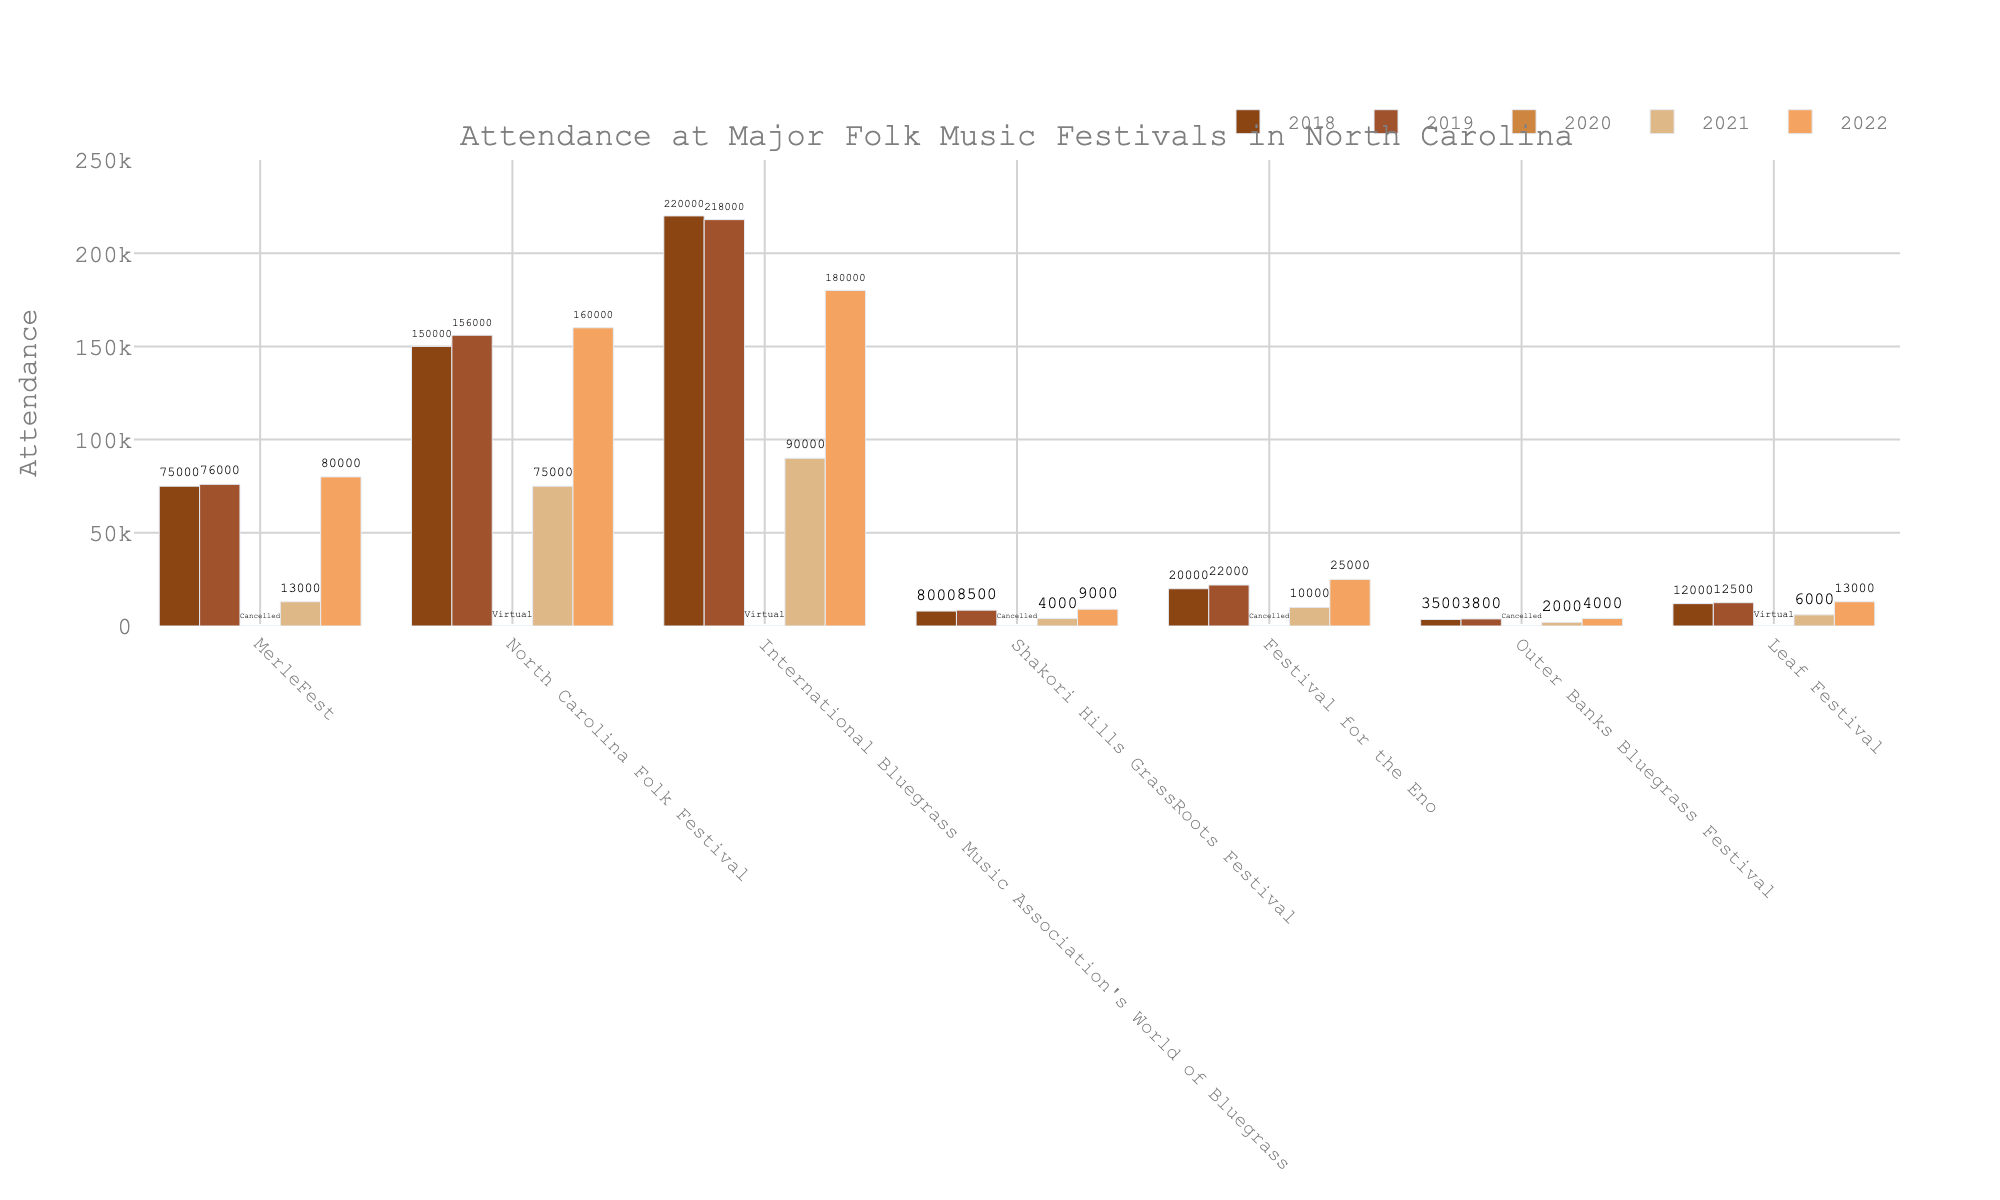Which festival had the highest attendance in 2022? Look for the tallest bar in the 2022 group. The "North Carolina Folk Festival" has the highest attendance with the tallest bar.
Answer: North Carolina Folk Festival How did the attendance for the "MerleFest" change from 2021 to 2022? Compare the bar heights for "MerleFest" between 2021 (13,000) and 2022 (80,000). The attendance increased.
Answer: Increased Which festivals were cancelled in 2020? Look for the festivals with a bar height of zero and having the label "Cancelled" in 2020. These are "MerleFest," "Shakori Hills GrassRoots Festival," "Festival for the Eno," and "Outer Banks Bluegrass Festival".
Answer: MerleFest, Shakori Hills GrassRoots Festival, Festival for the Eno, Outer Banks Bluegrass Festival What was the total attendance across all festivals in 2021? Sum the heights of all bars for 2021. MerleFest (13,000) + North Carolina Folk Festival (75,000) + International Bluegrass Music Association's World of Bluegrass (90,000) + Shakori Hills GrassRoots Festival (4,000) + Festival for the Eno (10,000) + Outer Banks Bluegrass Festival (2,000) + Leaf Festival (6,000) = 200,000.
Answer: 200,000 Did any festival have a virtual event in 2020, and if so, which ones? Identify bars labeled as "Virtual" for 2020. The festivals are "North Carolina Folk Festival," "International Bluegrass Music Association's World of Bluegrass," and "Leaf Festival".
Answer: North Carolina Folk Festival, International Bluegrass Music Association's World of Bluegrass, Leaf Festival Which festival had the lowest attendance in 2019? Identify the shortest bar in 2019. The shortest bar belongs to the "Outer Banks Bluegrass Festival" with 3,800 attendees.
Answer: Outer Banks Bluegrass Festival What is the difference in attendance for the "Festival for the Eno" between 2018 and 2022? Subtract the attendance in 2018 (20,000) from the attendance in 2022 (25,000). The difference is 25,000 - 20,000 = 5,000.
Answer: 5,000 How does the overall trend in attendance from 2018 to 2022 differ between "MerleFest" and "Leaf Festival"? Compare the heights of bars for each year for "MerleFest" and "Leaf Festival". "MerleFest" shows a decline in 2021 and an increase in 2022 back to levels higher than 2018, while "Leaf Festival" shows a dip in attendance in 2021 but a smaller overall change, remaining relatively stable over the years.
Answer: MerleFest: Varied significantly with a dip and recovery. Leaf Festival: Relatively stable 